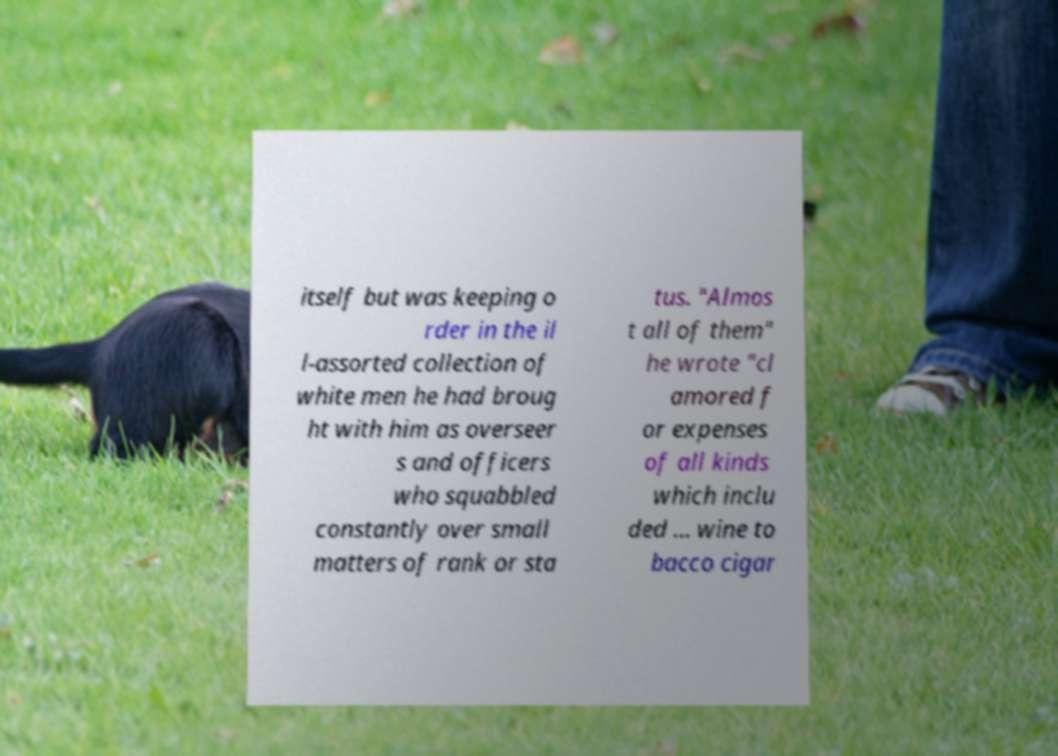Could you assist in decoding the text presented in this image and type it out clearly? itself but was keeping o rder in the il l-assorted collection of white men he had broug ht with him as overseer s and officers who squabbled constantly over small matters of rank or sta tus. "Almos t all of them" he wrote "cl amored f or expenses of all kinds which inclu ded ... wine to bacco cigar 